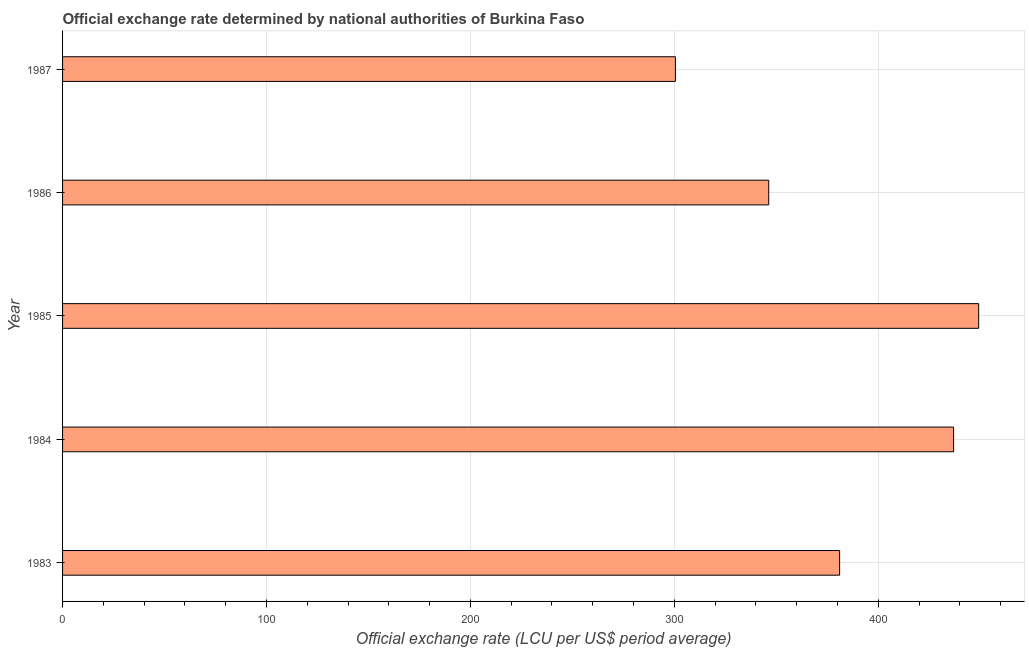Does the graph contain grids?
Keep it short and to the point. Yes. What is the title of the graph?
Your answer should be very brief. Official exchange rate determined by national authorities of Burkina Faso. What is the label or title of the X-axis?
Make the answer very short. Official exchange rate (LCU per US$ period average). What is the label or title of the Y-axis?
Ensure brevity in your answer.  Year. What is the official exchange rate in 1986?
Your answer should be compact. 346.31. Across all years, what is the maximum official exchange rate?
Give a very brief answer. 449.26. Across all years, what is the minimum official exchange rate?
Offer a terse response. 300.54. In which year was the official exchange rate minimum?
Make the answer very short. 1987. What is the sum of the official exchange rate?
Make the answer very short. 1914.13. What is the difference between the official exchange rate in 1984 and 1987?
Offer a very short reply. 136.42. What is the average official exchange rate per year?
Offer a terse response. 382.83. What is the median official exchange rate?
Provide a succinct answer. 381.07. Do a majority of the years between 1985 and 1983 (inclusive) have official exchange rate greater than 160 ?
Offer a very short reply. Yes. What is the ratio of the official exchange rate in 1983 to that in 1986?
Give a very brief answer. 1.1. Is the difference between the official exchange rate in 1984 and 1987 greater than the difference between any two years?
Give a very brief answer. No. What is the difference between the highest and the second highest official exchange rate?
Offer a very short reply. 12.31. What is the difference between the highest and the lowest official exchange rate?
Offer a terse response. 148.73. In how many years, is the official exchange rate greater than the average official exchange rate taken over all years?
Keep it short and to the point. 2. How many years are there in the graph?
Offer a very short reply. 5. Are the values on the major ticks of X-axis written in scientific E-notation?
Keep it short and to the point. No. What is the Official exchange rate (LCU per US$ period average) in 1983?
Ensure brevity in your answer.  381.07. What is the Official exchange rate (LCU per US$ period average) of 1984?
Offer a terse response. 436.96. What is the Official exchange rate (LCU per US$ period average) in 1985?
Offer a very short reply. 449.26. What is the Official exchange rate (LCU per US$ period average) in 1986?
Keep it short and to the point. 346.31. What is the Official exchange rate (LCU per US$ period average) in 1987?
Offer a very short reply. 300.54. What is the difference between the Official exchange rate (LCU per US$ period average) in 1983 and 1984?
Your response must be concise. -55.89. What is the difference between the Official exchange rate (LCU per US$ period average) in 1983 and 1985?
Your answer should be compact. -68.2. What is the difference between the Official exchange rate (LCU per US$ period average) in 1983 and 1986?
Ensure brevity in your answer.  34.76. What is the difference between the Official exchange rate (LCU per US$ period average) in 1983 and 1987?
Your response must be concise. 80.53. What is the difference between the Official exchange rate (LCU per US$ period average) in 1984 and 1985?
Your response must be concise. -12.31. What is the difference between the Official exchange rate (LCU per US$ period average) in 1984 and 1986?
Provide a succinct answer. 90.65. What is the difference between the Official exchange rate (LCU per US$ period average) in 1984 and 1987?
Your response must be concise. 136.42. What is the difference between the Official exchange rate (LCU per US$ period average) in 1985 and 1986?
Ensure brevity in your answer.  102.96. What is the difference between the Official exchange rate (LCU per US$ period average) in 1985 and 1987?
Provide a short and direct response. 148.73. What is the difference between the Official exchange rate (LCU per US$ period average) in 1986 and 1987?
Your response must be concise. 45.77. What is the ratio of the Official exchange rate (LCU per US$ period average) in 1983 to that in 1984?
Your answer should be very brief. 0.87. What is the ratio of the Official exchange rate (LCU per US$ period average) in 1983 to that in 1985?
Make the answer very short. 0.85. What is the ratio of the Official exchange rate (LCU per US$ period average) in 1983 to that in 1987?
Give a very brief answer. 1.27. What is the ratio of the Official exchange rate (LCU per US$ period average) in 1984 to that in 1985?
Give a very brief answer. 0.97. What is the ratio of the Official exchange rate (LCU per US$ period average) in 1984 to that in 1986?
Your answer should be very brief. 1.26. What is the ratio of the Official exchange rate (LCU per US$ period average) in 1984 to that in 1987?
Keep it short and to the point. 1.45. What is the ratio of the Official exchange rate (LCU per US$ period average) in 1985 to that in 1986?
Provide a short and direct response. 1.3. What is the ratio of the Official exchange rate (LCU per US$ period average) in 1985 to that in 1987?
Make the answer very short. 1.5. What is the ratio of the Official exchange rate (LCU per US$ period average) in 1986 to that in 1987?
Keep it short and to the point. 1.15. 